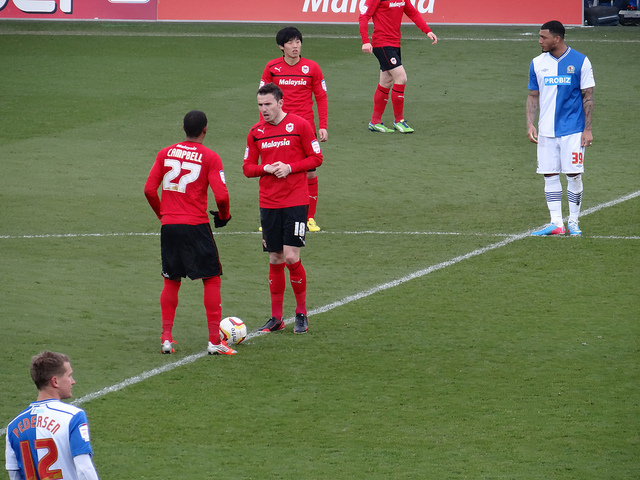Identify the text displayed in this image. 18 CAMPBELL 27 Malaysia Maloytla 12 PEDERSEA PROBIZ 39 